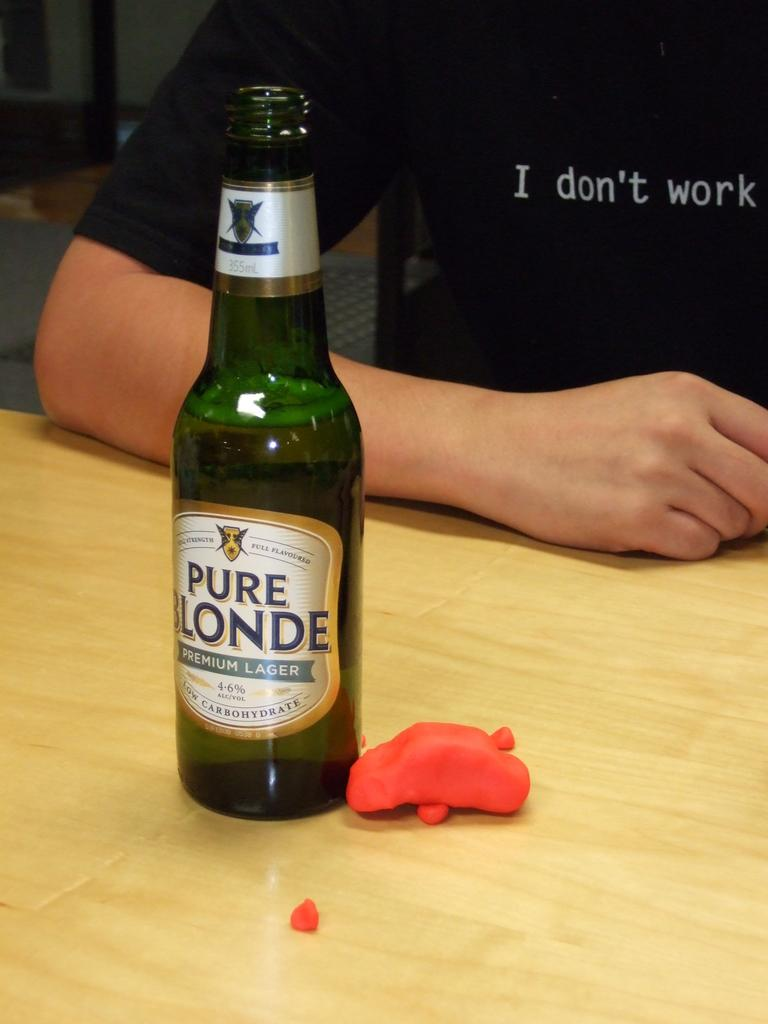<image>
Describe the image concisely. a Pure Londe drink bottle with someone who doesn't work next to it. 